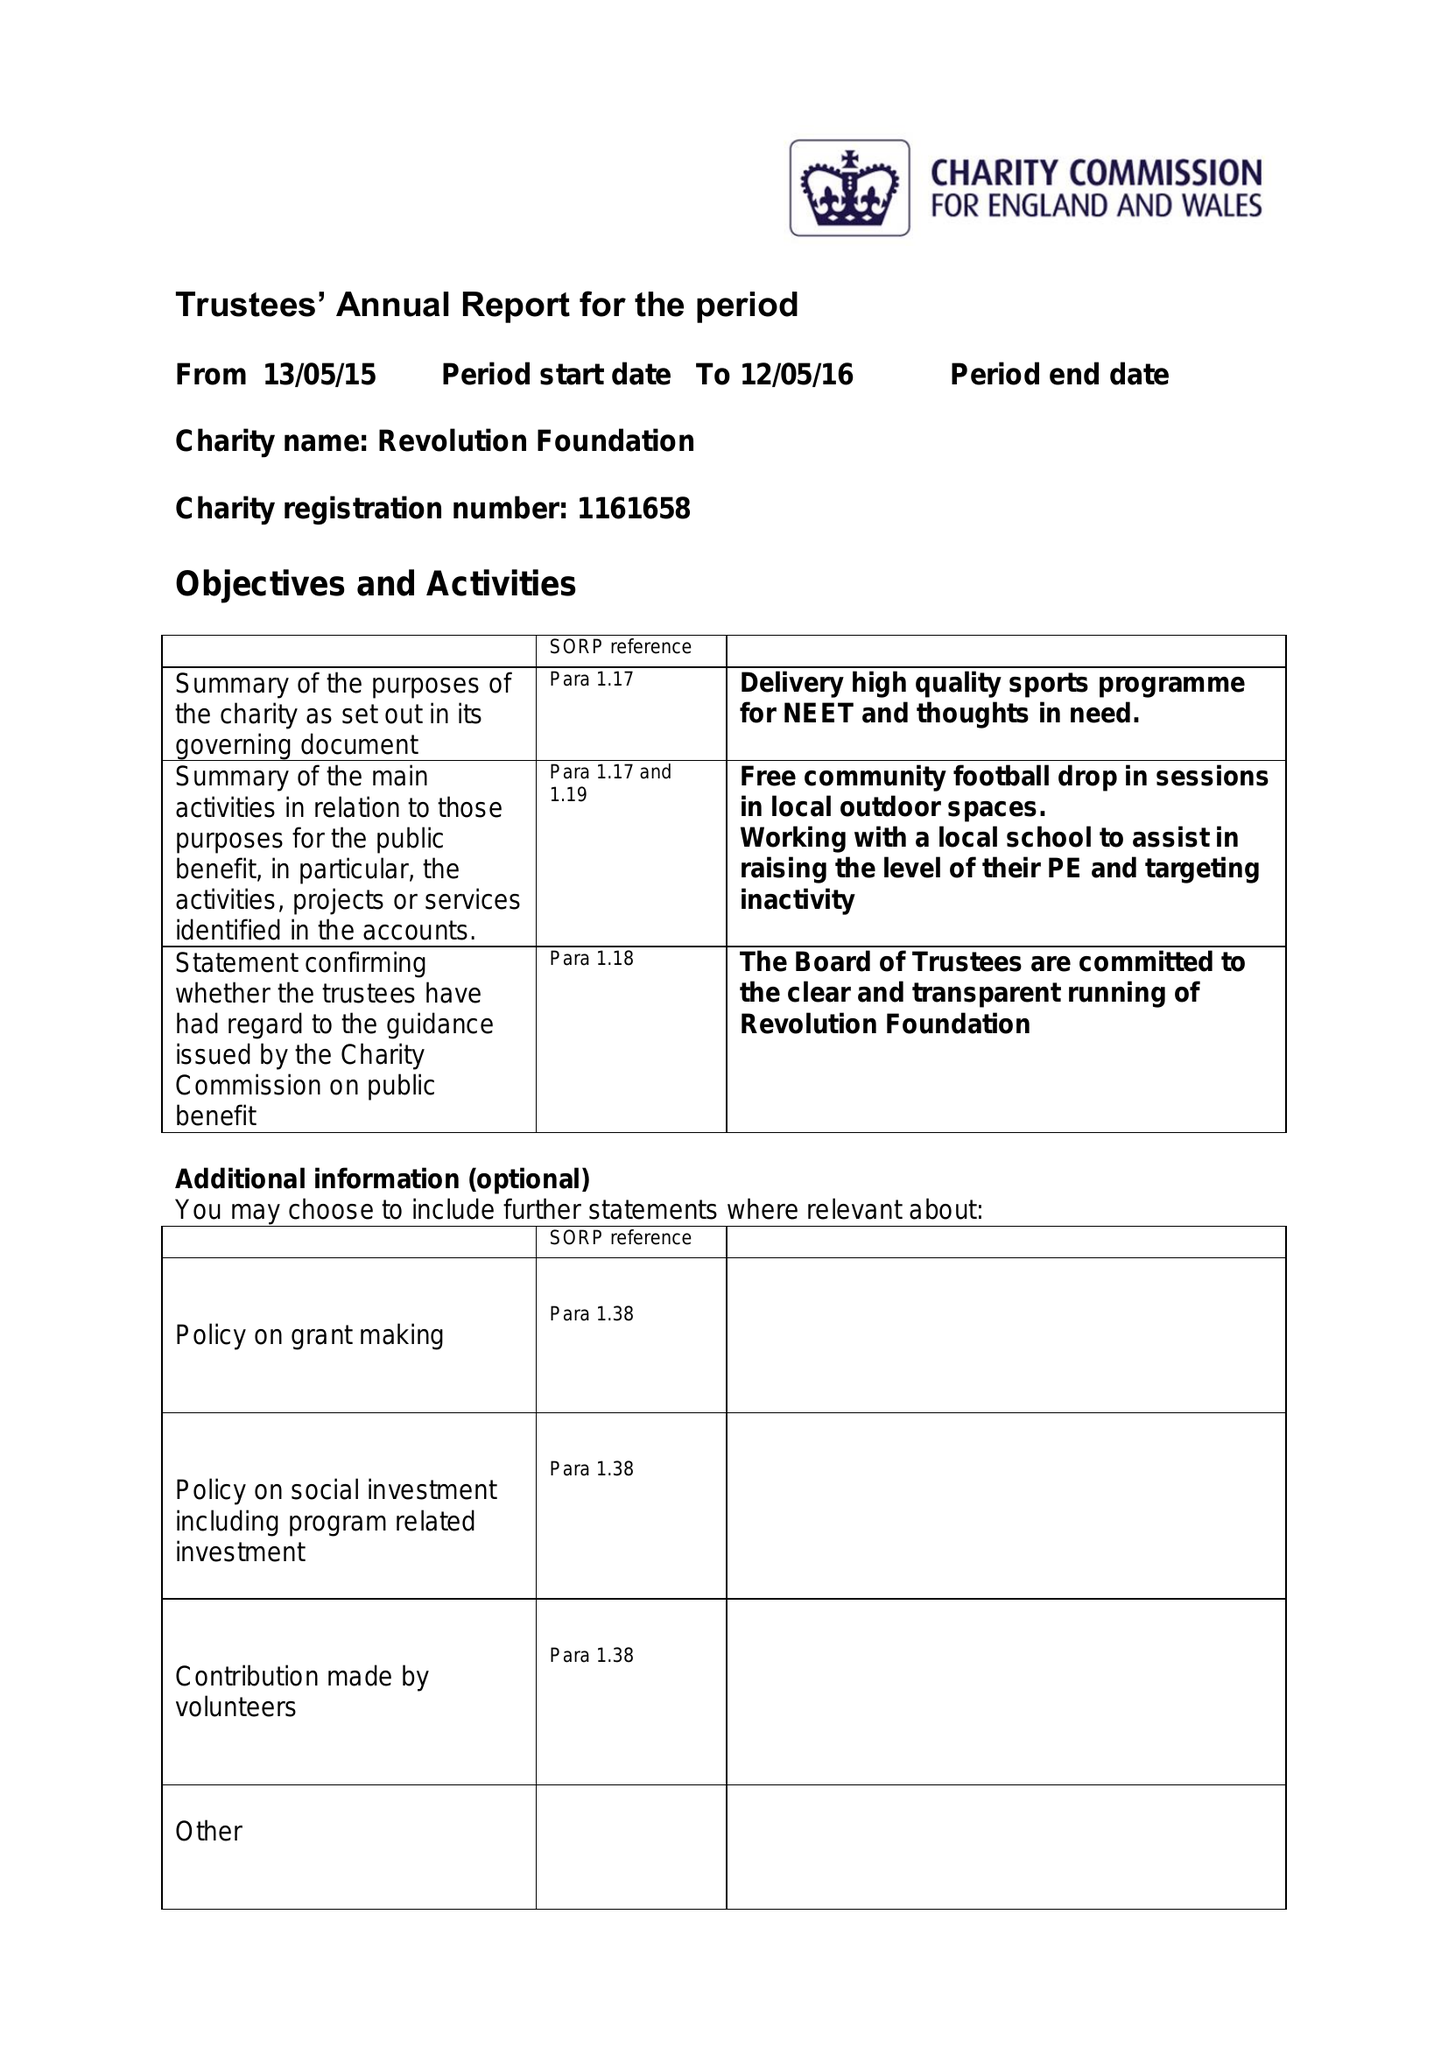What is the value for the spending_annually_in_british_pounds?
Answer the question using a single word or phrase. 1944.00 